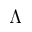<formula> <loc_0><loc_0><loc_500><loc_500>\Lambda</formula> 